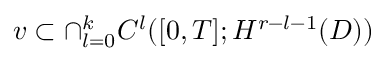<formula> <loc_0><loc_0><loc_500><loc_500>v \subset \cap _ { l = 0 } ^ { k } C ^ { l } ( [ 0 , T ] ; H ^ { r - l - 1 } ( D ) )</formula> 